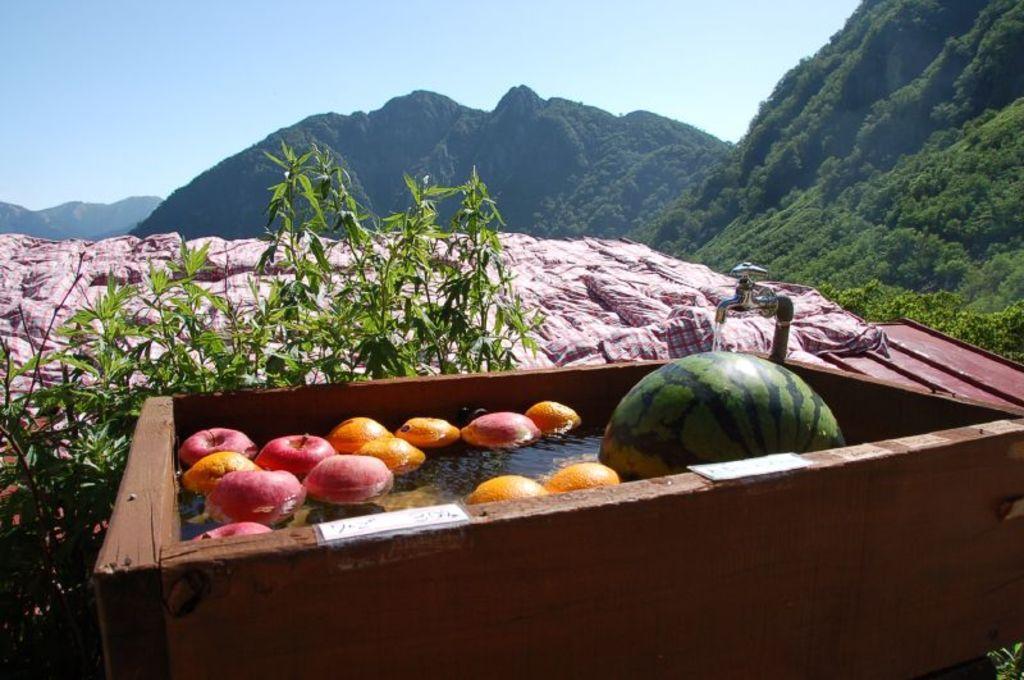How would you summarize this image in a sentence or two? In this image there are some fruits in a wooden basket, the wooden basket is filled with water from the tap beside it, behind the basket there is a plant, behind the plant there is a rooftop covered with a cover. In the background of the image there are mountains. 